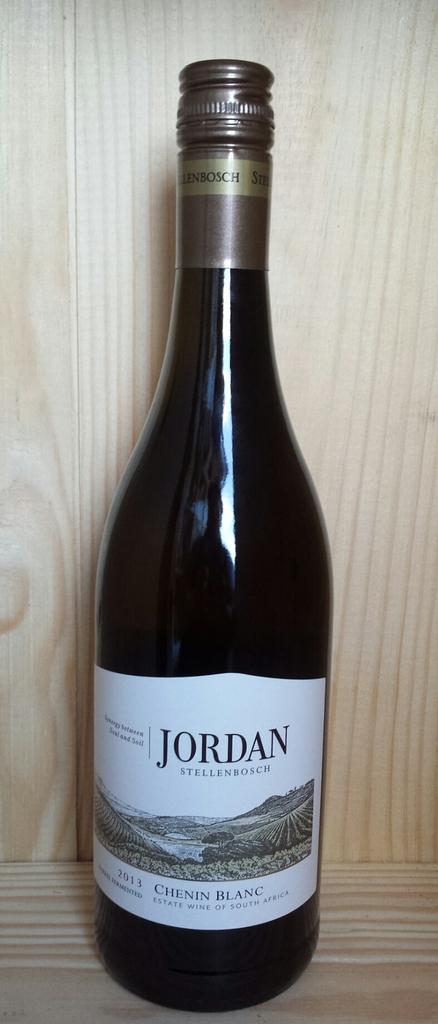What is the name of this wine?
Your answer should be very brief. Jordan. 